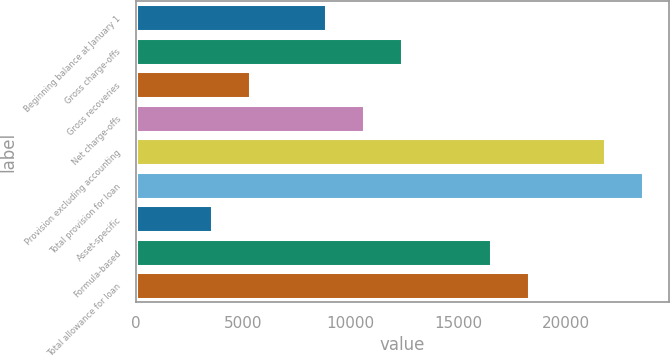Convert chart. <chart><loc_0><loc_0><loc_500><loc_500><bar_chart><fcel>Beginning balance at January 1<fcel>Gross charge-offs<fcel>Gross recoveries<fcel>Net charge-offs<fcel>Provision excluding accounting<fcel>Total provision for loan<fcel>Asset-specific<fcel>Formula-based<fcel>Total allowance for loan<nl><fcel>8863<fcel>12398.2<fcel>5327.8<fcel>10630.6<fcel>21847.8<fcel>23615.4<fcel>3560.2<fcel>16545<fcel>18312.6<nl></chart> 